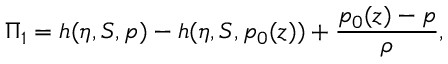Convert formula to latex. <formula><loc_0><loc_0><loc_500><loc_500>\Pi _ { 1 } = h ( \eta , S , p ) - h ( \eta , S , p _ { 0 } ( z ) ) + \frac { p _ { 0 } ( z ) - p } { \rho } ,</formula> 